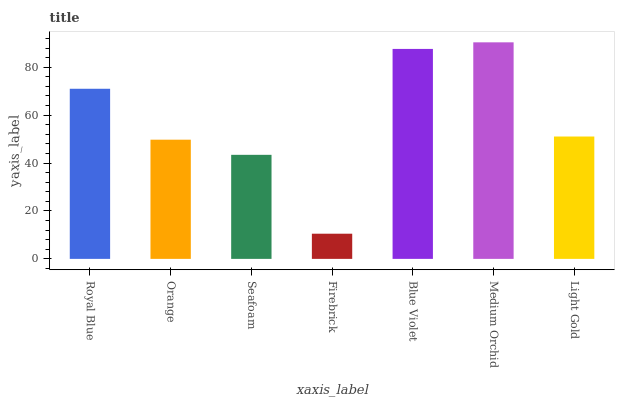Is Firebrick the minimum?
Answer yes or no. Yes. Is Medium Orchid the maximum?
Answer yes or no. Yes. Is Orange the minimum?
Answer yes or no. No. Is Orange the maximum?
Answer yes or no. No. Is Royal Blue greater than Orange?
Answer yes or no. Yes. Is Orange less than Royal Blue?
Answer yes or no. Yes. Is Orange greater than Royal Blue?
Answer yes or no. No. Is Royal Blue less than Orange?
Answer yes or no. No. Is Light Gold the high median?
Answer yes or no. Yes. Is Light Gold the low median?
Answer yes or no. Yes. Is Orange the high median?
Answer yes or no. No. Is Seafoam the low median?
Answer yes or no. No. 